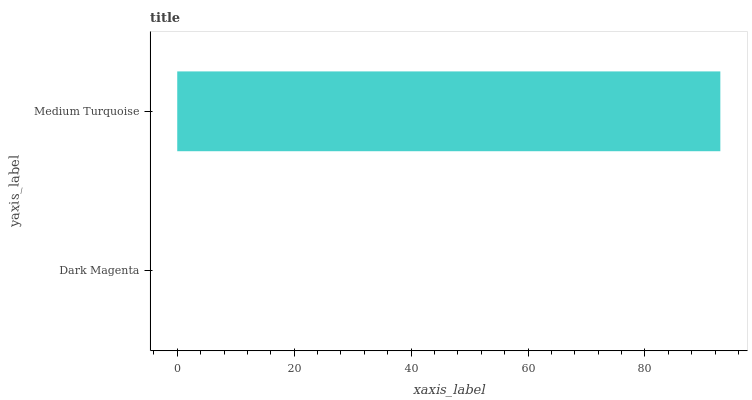Is Dark Magenta the minimum?
Answer yes or no. Yes. Is Medium Turquoise the maximum?
Answer yes or no. Yes. Is Medium Turquoise the minimum?
Answer yes or no. No. Is Medium Turquoise greater than Dark Magenta?
Answer yes or no. Yes. Is Dark Magenta less than Medium Turquoise?
Answer yes or no. Yes. Is Dark Magenta greater than Medium Turquoise?
Answer yes or no. No. Is Medium Turquoise less than Dark Magenta?
Answer yes or no. No. Is Medium Turquoise the high median?
Answer yes or no. Yes. Is Dark Magenta the low median?
Answer yes or no. Yes. Is Dark Magenta the high median?
Answer yes or no. No. Is Medium Turquoise the low median?
Answer yes or no. No. 